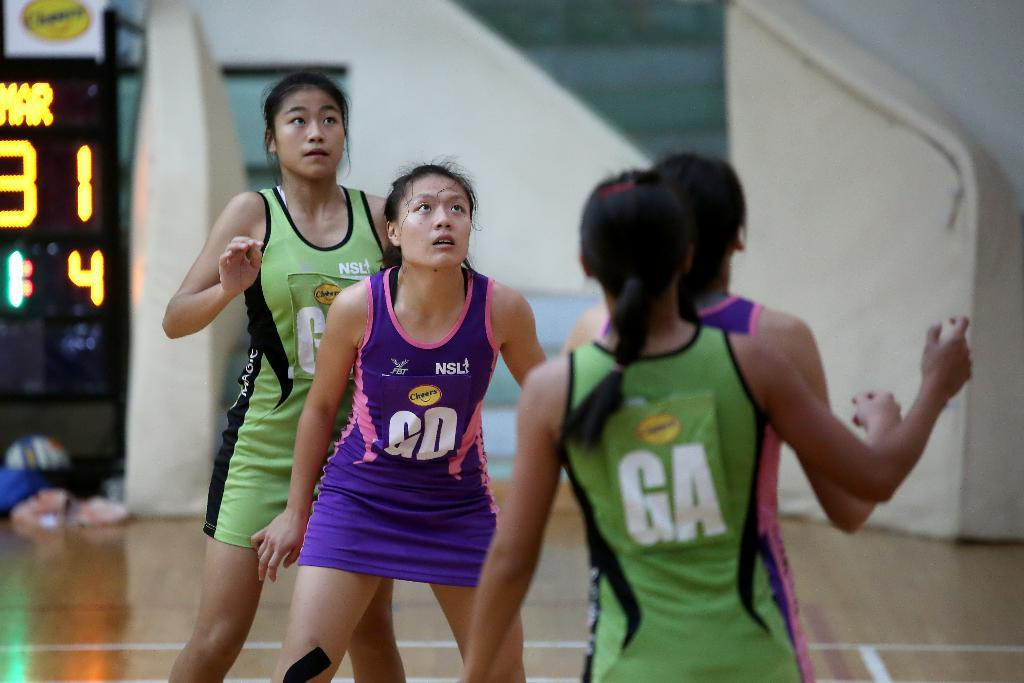How many people are in the image? There are four girls standing in the image. What can be seen on the left side of the image? There is a digital screen on the left side of the image. Can you describe the background of the image? The background of the image appears blurry. What type of nerve can be seen in the image? There is no nerve present in the image. What season is depicted in the image? The provided facts do not mention any season, so it cannot be determined from the image. 